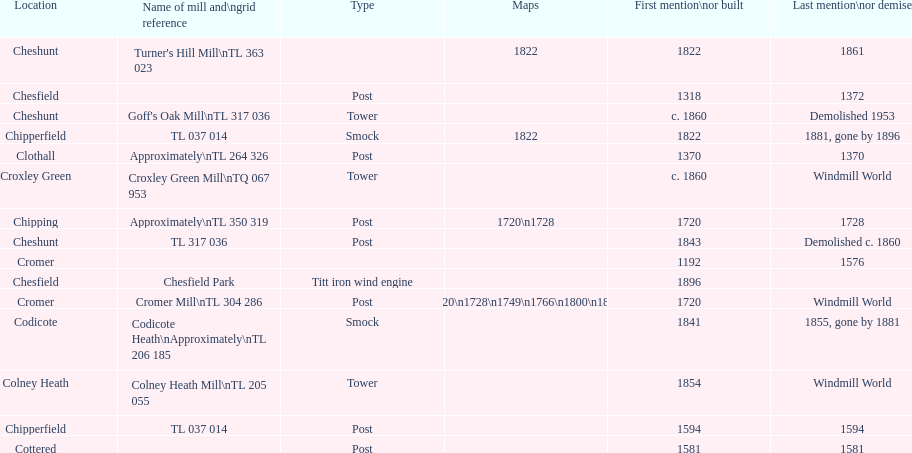What is the total number of mills named cheshunt? 3. 